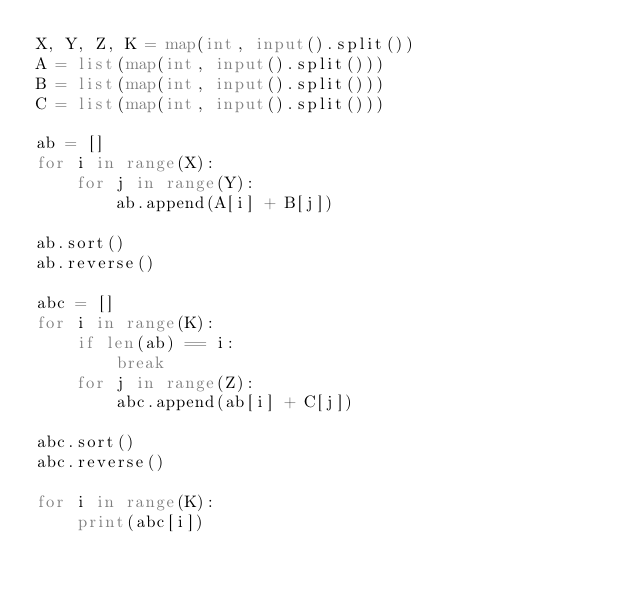<code> <loc_0><loc_0><loc_500><loc_500><_Python_>X, Y, Z, K = map(int, input().split())
A = list(map(int, input().split()))
B = list(map(int, input().split()))
C = list(map(int, input().split()))

ab = []
for i in range(X):
    for j in range(Y):
        ab.append(A[i] + B[j])

ab.sort()
ab.reverse()

abc = []
for i in range(K):
    if len(ab) == i:
        break
    for j in range(Z):
        abc.append(ab[i] + C[j])

abc.sort()
abc.reverse()

for i in range(K):
    print(abc[i])
</code> 